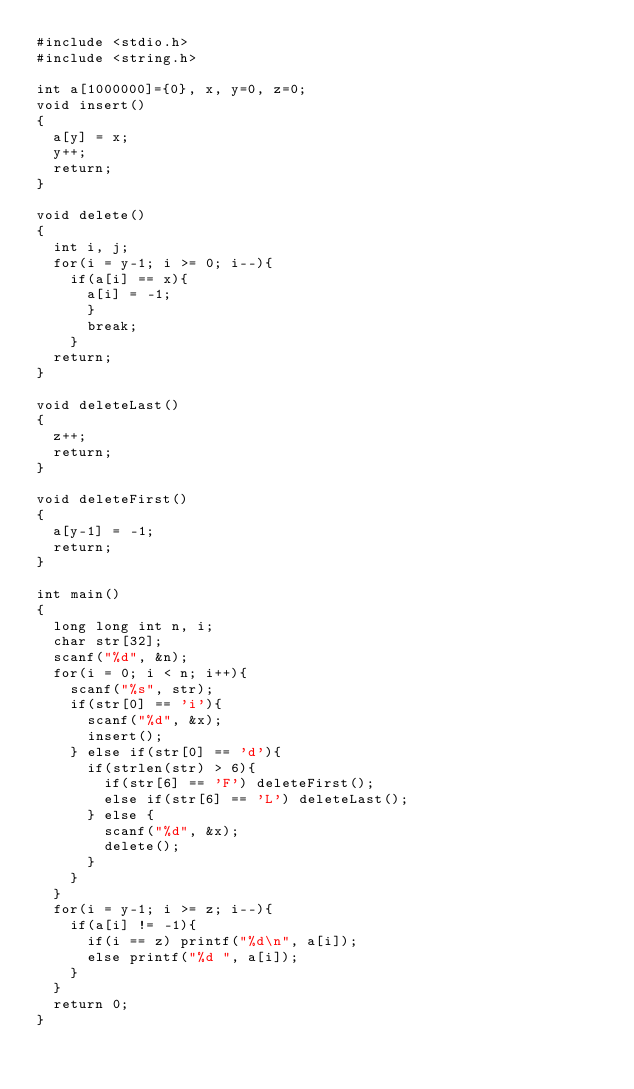Convert code to text. <code><loc_0><loc_0><loc_500><loc_500><_C_>#include <stdio.h>
#include <string.h>

int a[1000000]={0}, x, y=0, z=0;
void insert()
{
  a[y] = x;
  y++;
  return;
}

void delete()
{
  int i, j;
  for(i = y-1; i >= 0; i--){
    if(a[i] == x){
      a[i] = -1;
      }
      break;
    }
  return;
}

void deleteLast()
{
  z++;
  return;
}

void deleteFirst()
{
  a[y-1] = -1;
  return;
}

int main()
{
  long long int n, i;
  char str[32];
  scanf("%d", &n);
  for(i = 0; i < n; i++){
    scanf("%s", str);
    if(str[0] == 'i'){
      scanf("%d", &x);
      insert();
    } else if(str[0] == 'd'){
      if(strlen(str) > 6){
        if(str[6] == 'F') deleteFirst();
        else if(str[6] == 'L') deleteLast();
      } else {
        scanf("%d", &x);
        delete();
      }    
    }
  }
  for(i = y-1; i >= z; i--){
    if(a[i] != -1){
      if(i == z) printf("%d\n", a[i]);
      else printf("%d ", a[i]);
    }
  }
  return 0;
}</code> 